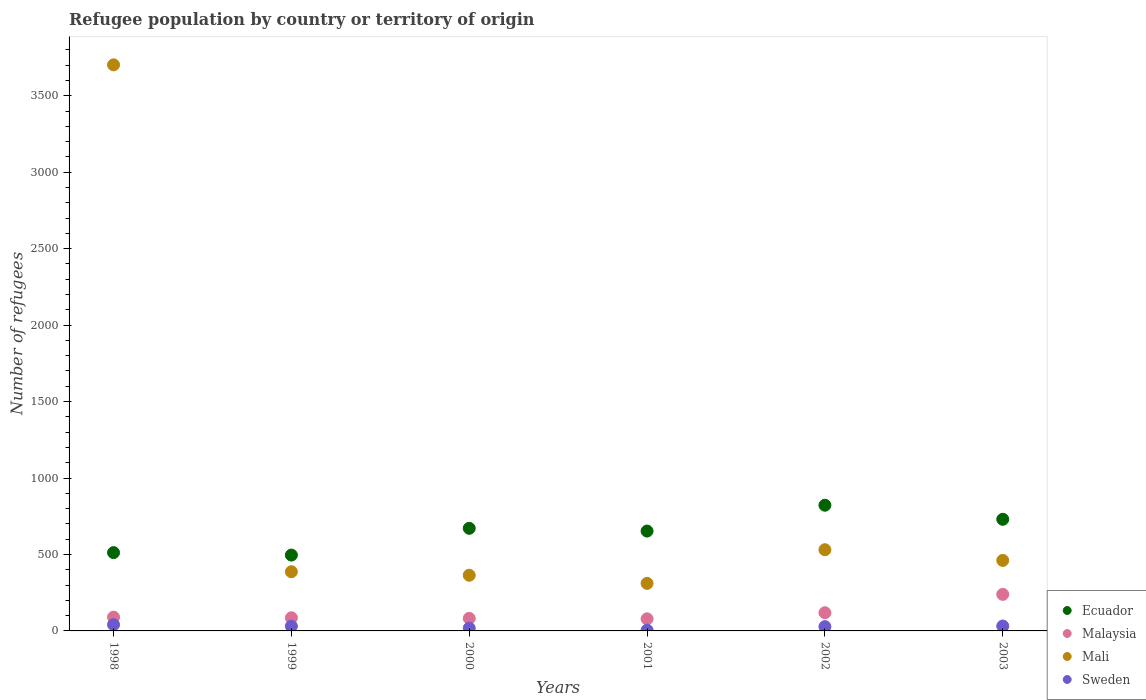How many different coloured dotlines are there?
Offer a terse response. 4. Is the number of dotlines equal to the number of legend labels?
Your answer should be compact. Yes. What is the number of refugees in Mali in 1998?
Keep it short and to the point. 3702. Across all years, what is the maximum number of refugees in Mali?
Your response must be concise. 3702. Across all years, what is the minimum number of refugees in Malaysia?
Keep it short and to the point. 79. What is the total number of refugees in Mali in the graph?
Your answer should be compact. 5756. What is the difference between the number of refugees in Sweden in 1998 and that in 1999?
Offer a terse response. 10. What is the difference between the number of refugees in Ecuador in 1999 and the number of refugees in Mali in 2001?
Your answer should be very brief. 185. What is the average number of refugees in Sweden per year?
Your response must be concise. 25.83. In the year 1999, what is the difference between the number of refugees in Malaysia and number of refugees in Ecuador?
Provide a short and direct response. -410. What is the ratio of the number of refugees in Malaysia in 2000 to that in 2001?
Provide a short and direct response. 1.04. Is the difference between the number of refugees in Malaysia in 1998 and 1999 greater than the difference between the number of refugees in Ecuador in 1998 and 1999?
Offer a very short reply. No. What is the difference between the highest and the second highest number of refugees in Mali?
Your answer should be very brief. 3171. Is it the case that in every year, the sum of the number of refugees in Mali and number of refugees in Malaysia  is greater than the sum of number of refugees in Sweden and number of refugees in Ecuador?
Make the answer very short. No. Is it the case that in every year, the sum of the number of refugees in Malaysia and number of refugees in Ecuador  is greater than the number of refugees in Sweden?
Make the answer very short. Yes. Is the number of refugees in Ecuador strictly greater than the number of refugees in Malaysia over the years?
Your response must be concise. Yes. Is the number of refugees in Ecuador strictly less than the number of refugees in Malaysia over the years?
Provide a short and direct response. No. How many dotlines are there?
Give a very brief answer. 4. How many years are there in the graph?
Give a very brief answer. 6. Does the graph contain grids?
Your answer should be compact. No. Where does the legend appear in the graph?
Your answer should be compact. Bottom right. What is the title of the graph?
Offer a terse response. Refugee population by country or territory of origin. What is the label or title of the X-axis?
Ensure brevity in your answer.  Years. What is the label or title of the Y-axis?
Your answer should be compact. Number of refugees. What is the Number of refugees in Ecuador in 1998?
Your response must be concise. 512. What is the Number of refugees of Malaysia in 1998?
Your response must be concise. 90. What is the Number of refugees of Mali in 1998?
Provide a short and direct response. 3702. What is the Number of refugees of Sweden in 1998?
Ensure brevity in your answer.  41. What is the Number of refugees in Ecuador in 1999?
Give a very brief answer. 496. What is the Number of refugees in Malaysia in 1999?
Your response must be concise. 86. What is the Number of refugees in Mali in 1999?
Make the answer very short. 387. What is the Number of refugees in Ecuador in 2000?
Provide a short and direct response. 671. What is the Number of refugees in Mali in 2000?
Offer a very short reply. 364. What is the Number of refugees of Sweden in 2000?
Make the answer very short. 18. What is the Number of refugees in Ecuador in 2001?
Make the answer very short. 653. What is the Number of refugees of Malaysia in 2001?
Your answer should be very brief. 79. What is the Number of refugees in Mali in 2001?
Offer a very short reply. 311. What is the Number of refugees of Sweden in 2001?
Ensure brevity in your answer.  5. What is the Number of refugees of Ecuador in 2002?
Provide a succinct answer. 822. What is the Number of refugees in Malaysia in 2002?
Make the answer very short. 119. What is the Number of refugees in Mali in 2002?
Your response must be concise. 531. What is the Number of refugees in Sweden in 2002?
Keep it short and to the point. 28. What is the Number of refugees of Ecuador in 2003?
Keep it short and to the point. 730. What is the Number of refugees in Malaysia in 2003?
Give a very brief answer. 239. What is the Number of refugees in Mali in 2003?
Ensure brevity in your answer.  461. Across all years, what is the maximum Number of refugees of Ecuador?
Ensure brevity in your answer.  822. Across all years, what is the maximum Number of refugees in Malaysia?
Keep it short and to the point. 239. Across all years, what is the maximum Number of refugees of Mali?
Keep it short and to the point. 3702. Across all years, what is the minimum Number of refugees of Ecuador?
Offer a terse response. 496. Across all years, what is the minimum Number of refugees in Malaysia?
Offer a terse response. 79. Across all years, what is the minimum Number of refugees in Mali?
Your answer should be compact. 311. Across all years, what is the minimum Number of refugees in Sweden?
Give a very brief answer. 5. What is the total Number of refugees in Ecuador in the graph?
Ensure brevity in your answer.  3884. What is the total Number of refugees in Malaysia in the graph?
Your response must be concise. 695. What is the total Number of refugees of Mali in the graph?
Ensure brevity in your answer.  5756. What is the total Number of refugees of Sweden in the graph?
Your answer should be very brief. 155. What is the difference between the Number of refugees of Ecuador in 1998 and that in 1999?
Offer a terse response. 16. What is the difference between the Number of refugees in Mali in 1998 and that in 1999?
Keep it short and to the point. 3315. What is the difference between the Number of refugees in Ecuador in 1998 and that in 2000?
Provide a short and direct response. -159. What is the difference between the Number of refugees in Mali in 1998 and that in 2000?
Keep it short and to the point. 3338. What is the difference between the Number of refugees of Ecuador in 1998 and that in 2001?
Your answer should be very brief. -141. What is the difference between the Number of refugees of Mali in 1998 and that in 2001?
Give a very brief answer. 3391. What is the difference between the Number of refugees of Ecuador in 1998 and that in 2002?
Offer a terse response. -310. What is the difference between the Number of refugees in Mali in 1998 and that in 2002?
Ensure brevity in your answer.  3171. What is the difference between the Number of refugees of Ecuador in 1998 and that in 2003?
Provide a short and direct response. -218. What is the difference between the Number of refugees in Malaysia in 1998 and that in 2003?
Your answer should be compact. -149. What is the difference between the Number of refugees of Mali in 1998 and that in 2003?
Offer a terse response. 3241. What is the difference between the Number of refugees of Sweden in 1998 and that in 2003?
Your answer should be compact. 9. What is the difference between the Number of refugees in Ecuador in 1999 and that in 2000?
Provide a short and direct response. -175. What is the difference between the Number of refugees in Malaysia in 1999 and that in 2000?
Give a very brief answer. 4. What is the difference between the Number of refugees in Ecuador in 1999 and that in 2001?
Ensure brevity in your answer.  -157. What is the difference between the Number of refugees in Mali in 1999 and that in 2001?
Offer a terse response. 76. What is the difference between the Number of refugees of Ecuador in 1999 and that in 2002?
Ensure brevity in your answer.  -326. What is the difference between the Number of refugees in Malaysia in 1999 and that in 2002?
Give a very brief answer. -33. What is the difference between the Number of refugees in Mali in 1999 and that in 2002?
Your answer should be very brief. -144. What is the difference between the Number of refugees of Sweden in 1999 and that in 2002?
Your response must be concise. 3. What is the difference between the Number of refugees in Ecuador in 1999 and that in 2003?
Offer a very short reply. -234. What is the difference between the Number of refugees in Malaysia in 1999 and that in 2003?
Provide a short and direct response. -153. What is the difference between the Number of refugees in Mali in 1999 and that in 2003?
Your answer should be compact. -74. What is the difference between the Number of refugees of Sweden in 1999 and that in 2003?
Your answer should be very brief. -1. What is the difference between the Number of refugees in Ecuador in 2000 and that in 2001?
Offer a very short reply. 18. What is the difference between the Number of refugees in Malaysia in 2000 and that in 2001?
Ensure brevity in your answer.  3. What is the difference between the Number of refugees of Ecuador in 2000 and that in 2002?
Offer a terse response. -151. What is the difference between the Number of refugees of Malaysia in 2000 and that in 2002?
Provide a short and direct response. -37. What is the difference between the Number of refugees in Mali in 2000 and that in 2002?
Your response must be concise. -167. What is the difference between the Number of refugees of Sweden in 2000 and that in 2002?
Your response must be concise. -10. What is the difference between the Number of refugees of Ecuador in 2000 and that in 2003?
Provide a short and direct response. -59. What is the difference between the Number of refugees in Malaysia in 2000 and that in 2003?
Provide a short and direct response. -157. What is the difference between the Number of refugees in Mali in 2000 and that in 2003?
Your answer should be compact. -97. What is the difference between the Number of refugees of Ecuador in 2001 and that in 2002?
Keep it short and to the point. -169. What is the difference between the Number of refugees in Mali in 2001 and that in 2002?
Offer a terse response. -220. What is the difference between the Number of refugees in Sweden in 2001 and that in 2002?
Offer a very short reply. -23. What is the difference between the Number of refugees in Ecuador in 2001 and that in 2003?
Offer a terse response. -77. What is the difference between the Number of refugees of Malaysia in 2001 and that in 2003?
Keep it short and to the point. -160. What is the difference between the Number of refugees of Mali in 2001 and that in 2003?
Ensure brevity in your answer.  -150. What is the difference between the Number of refugees of Ecuador in 2002 and that in 2003?
Ensure brevity in your answer.  92. What is the difference between the Number of refugees of Malaysia in 2002 and that in 2003?
Keep it short and to the point. -120. What is the difference between the Number of refugees in Mali in 2002 and that in 2003?
Give a very brief answer. 70. What is the difference between the Number of refugees in Sweden in 2002 and that in 2003?
Provide a short and direct response. -4. What is the difference between the Number of refugees in Ecuador in 1998 and the Number of refugees in Malaysia in 1999?
Give a very brief answer. 426. What is the difference between the Number of refugees in Ecuador in 1998 and the Number of refugees in Mali in 1999?
Provide a succinct answer. 125. What is the difference between the Number of refugees of Ecuador in 1998 and the Number of refugees of Sweden in 1999?
Provide a short and direct response. 481. What is the difference between the Number of refugees in Malaysia in 1998 and the Number of refugees in Mali in 1999?
Keep it short and to the point. -297. What is the difference between the Number of refugees of Malaysia in 1998 and the Number of refugees of Sweden in 1999?
Your answer should be very brief. 59. What is the difference between the Number of refugees in Mali in 1998 and the Number of refugees in Sweden in 1999?
Offer a very short reply. 3671. What is the difference between the Number of refugees of Ecuador in 1998 and the Number of refugees of Malaysia in 2000?
Keep it short and to the point. 430. What is the difference between the Number of refugees in Ecuador in 1998 and the Number of refugees in Mali in 2000?
Offer a terse response. 148. What is the difference between the Number of refugees of Ecuador in 1998 and the Number of refugees of Sweden in 2000?
Your answer should be compact. 494. What is the difference between the Number of refugees in Malaysia in 1998 and the Number of refugees in Mali in 2000?
Your answer should be compact. -274. What is the difference between the Number of refugees of Mali in 1998 and the Number of refugees of Sweden in 2000?
Your answer should be very brief. 3684. What is the difference between the Number of refugees in Ecuador in 1998 and the Number of refugees in Malaysia in 2001?
Provide a succinct answer. 433. What is the difference between the Number of refugees of Ecuador in 1998 and the Number of refugees of Mali in 2001?
Your answer should be very brief. 201. What is the difference between the Number of refugees of Ecuador in 1998 and the Number of refugees of Sweden in 2001?
Offer a terse response. 507. What is the difference between the Number of refugees of Malaysia in 1998 and the Number of refugees of Mali in 2001?
Offer a terse response. -221. What is the difference between the Number of refugees in Malaysia in 1998 and the Number of refugees in Sweden in 2001?
Offer a terse response. 85. What is the difference between the Number of refugees in Mali in 1998 and the Number of refugees in Sweden in 2001?
Keep it short and to the point. 3697. What is the difference between the Number of refugees in Ecuador in 1998 and the Number of refugees in Malaysia in 2002?
Your answer should be compact. 393. What is the difference between the Number of refugees in Ecuador in 1998 and the Number of refugees in Sweden in 2002?
Keep it short and to the point. 484. What is the difference between the Number of refugees in Malaysia in 1998 and the Number of refugees in Mali in 2002?
Your answer should be very brief. -441. What is the difference between the Number of refugees of Malaysia in 1998 and the Number of refugees of Sweden in 2002?
Ensure brevity in your answer.  62. What is the difference between the Number of refugees of Mali in 1998 and the Number of refugees of Sweden in 2002?
Provide a short and direct response. 3674. What is the difference between the Number of refugees of Ecuador in 1998 and the Number of refugees of Malaysia in 2003?
Your answer should be compact. 273. What is the difference between the Number of refugees of Ecuador in 1998 and the Number of refugees of Mali in 2003?
Your response must be concise. 51. What is the difference between the Number of refugees of Ecuador in 1998 and the Number of refugees of Sweden in 2003?
Your answer should be very brief. 480. What is the difference between the Number of refugees of Malaysia in 1998 and the Number of refugees of Mali in 2003?
Offer a very short reply. -371. What is the difference between the Number of refugees of Mali in 1998 and the Number of refugees of Sweden in 2003?
Give a very brief answer. 3670. What is the difference between the Number of refugees of Ecuador in 1999 and the Number of refugees of Malaysia in 2000?
Keep it short and to the point. 414. What is the difference between the Number of refugees in Ecuador in 1999 and the Number of refugees in Mali in 2000?
Offer a terse response. 132. What is the difference between the Number of refugees in Ecuador in 1999 and the Number of refugees in Sweden in 2000?
Your answer should be compact. 478. What is the difference between the Number of refugees of Malaysia in 1999 and the Number of refugees of Mali in 2000?
Your response must be concise. -278. What is the difference between the Number of refugees of Mali in 1999 and the Number of refugees of Sweden in 2000?
Provide a succinct answer. 369. What is the difference between the Number of refugees of Ecuador in 1999 and the Number of refugees of Malaysia in 2001?
Offer a terse response. 417. What is the difference between the Number of refugees of Ecuador in 1999 and the Number of refugees of Mali in 2001?
Ensure brevity in your answer.  185. What is the difference between the Number of refugees of Ecuador in 1999 and the Number of refugees of Sweden in 2001?
Your answer should be very brief. 491. What is the difference between the Number of refugees in Malaysia in 1999 and the Number of refugees in Mali in 2001?
Make the answer very short. -225. What is the difference between the Number of refugees of Mali in 1999 and the Number of refugees of Sweden in 2001?
Give a very brief answer. 382. What is the difference between the Number of refugees in Ecuador in 1999 and the Number of refugees in Malaysia in 2002?
Offer a very short reply. 377. What is the difference between the Number of refugees in Ecuador in 1999 and the Number of refugees in Mali in 2002?
Give a very brief answer. -35. What is the difference between the Number of refugees of Ecuador in 1999 and the Number of refugees of Sweden in 2002?
Provide a succinct answer. 468. What is the difference between the Number of refugees of Malaysia in 1999 and the Number of refugees of Mali in 2002?
Provide a succinct answer. -445. What is the difference between the Number of refugees of Malaysia in 1999 and the Number of refugees of Sweden in 2002?
Make the answer very short. 58. What is the difference between the Number of refugees of Mali in 1999 and the Number of refugees of Sweden in 2002?
Offer a terse response. 359. What is the difference between the Number of refugees of Ecuador in 1999 and the Number of refugees of Malaysia in 2003?
Provide a succinct answer. 257. What is the difference between the Number of refugees of Ecuador in 1999 and the Number of refugees of Sweden in 2003?
Your answer should be very brief. 464. What is the difference between the Number of refugees of Malaysia in 1999 and the Number of refugees of Mali in 2003?
Provide a succinct answer. -375. What is the difference between the Number of refugees of Mali in 1999 and the Number of refugees of Sweden in 2003?
Offer a very short reply. 355. What is the difference between the Number of refugees in Ecuador in 2000 and the Number of refugees in Malaysia in 2001?
Ensure brevity in your answer.  592. What is the difference between the Number of refugees in Ecuador in 2000 and the Number of refugees in Mali in 2001?
Offer a terse response. 360. What is the difference between the Number of refugees of Ecuador in 2000 and the Number of refugees of Sweden in 2001?
Offer a terse response. 666. What is the difference between the Number of refugees of Malaysia in 2000 and the Number of refugees of Mali in 2001?
Provide a short and direct response. -229. What is the difference between the Number of refugees in Malaysia in 2000 and the Number of refugees in Sweden in 2001?
Your response must be concise. 77. What is the difference between the Number of refugees of Mali in 2000 and the Number of refugees of Sweden in 2001?
Your answer should be compact. 359. What is the difference between the Number of refugees in Ecuador in 2000 and the Number of refugees in Malaysia in 2002?
Your response must be concise. 552. What is the difference between the Number of refugees in Ecuador in 2000 and the Number of refugees in Mali in 2002?
Give a very brief answer. 140. What is the difference between the Number of refugees in Ecuador in 2000 and the Number of refugees in Sweden in 2002?
Your answer should be very brief. 643. What is the difference between the Number of refugees in Malaysia in 2000 and the Number of refugees in Mali in 2002?
Offer a terse response. -449. What is the difference between the Number of refugees of Mali in 2000 and the Number of refugees of Sweden in 2002?
Your answer should be very brief. 336. What is the difference between the Number of refugees in Ecuador in 2000 and the Number of refugees in Malaysia in 2003?
Offer a terse response. 432. What is the difference between the Number of refugees of Ecuador in 2000 and the Number of refugees of Mali in 2003?
Your answer should be very brief. 210. What is the difference between the Number of refugees of Ecuador in 2000 and the Number of refugees of Sweden in 2003?
Provide a short and direct response. 639. What is the difference between the Number of refugees in Malaysia in 2000 and the Number of refugees in Mali in 2003?
Your answer should be compact. -379. What is the difference between the Number of refugees of Malaysia in 2000 and the Number of refugees of Sweden in 2003?
Your response must be concise. 50. What is the difference between the Number of refugees of Mali in 2000 and the Number of refugees of Sweden in 2003?
Ensure brevity in your answer.  332. What is the difference between the Number of refugees in Ecuador in 2001 and the Number of refugees in Malaysia in 2002?
Provide a succinct answer. 534. What is the difference between the Number of refugees of Ecuador in 2001 and the Number of refugees of Mali in 2002?
Your answer should be compact. 122. What is the difference between the Number of refugees in Ecuador in 2001 and the Number of refugees in Sweden in 2002?
Give a very brief answer. 625. What is the difference between the Number of refugees in Malaysia in 2001 and the Number of refugees in Mali in 2002?
Offer a terse response. -452. What is the difference between the Number of refugees in Malaysia in 2001 and the Number of refugees in Sweden in 2002?
Offer a terse response. 51. What is the difference between the Number of refugees in Mali in 2001 and the Number of refugees in Sweden in 2002?
Provide a succinct answer. 283. What is the difference between the Number of refugees of Ecuador in 2001 and the Number of refugees of Malaysia in 2003?
Provide a short and direct response. 414. What is the difference between the Number of refugees in Ecuador in 2001 and the Number of refugees in Mali in 2003?
Provide a succinct answer. 192. What is the difference between the Number of refugees in Ecuador in 2001 and the Number of refugees in Sweden in 2003?
Make the answer very short. 621. What is the difference between the Number of refugees in Malaysia in 2001 and the Number of refugees in Mali in 2003?
Ensure brevity in your answer.  -382. What is the difference between the Number of refugees of Mali in 2001 and the Number of refugees of Sweden in 2003?
Your response must be concise. 279. What is the difference between the Number of refugees in Ecuador in 2002 and the Number of refugees in Malaysia in 2003?
Your answer should be very brief. 583. What is the difference between the Number of refugees in Ecuador in 2002 and the Number of refugees in Mali in 2003?
Provide a short and direct response. 361. What is the difference between the Number of refugees in Ecuador in 2002 and the Number of refugees in Sweden in 2003?
Your response must be concise. 790. What is the difference between the Number of refugees of Malaysia in 2002 and the Number of refugees of Mali in 2003?
Make the answer very short. -342. What is the difference between the Number of refugees of Malaysia in 2002 and the Number of refugees of Sweden in 2003?
Offer a terse response. 87. What is the difference between the Number of refugees of Mali in 2002 and the Number of refugees of Sweden in 2003?
Offer a terse response. 499. What is the average Number of refugees of Ecuador per year?
Ensure brevity in your answer.  647.33. What is the average Number of refugees of Malaysia per year?
Keep it short and to the point. 115.83. What is the average Number of refugees of Mali per year?
Your answer should be compact. 959.33. What is the average Number of refugees of Sweden per year?
Your response must be concise. 25.83. In the year 1998, what is the difference between the Number of refugees in Ecuador and Number of refugees in Malaysia?
Your response must be concise. 422. In the year 1998, what is the difference between the Number of refugees of Ecuador and Number of refugees of Mali?
Keep it short and to the point. -3190. In the year 1998, what is the difference between the Number of refugees in Ecuador and Number of refugees in Sweden?
Give a very brief answer. 471. In the year 1998, what is the difference between the Number of refugees of Malaysia and Number of refugees of Mali?
Provide a succinct answer. -3612. In the year 1998, what is the difference between the Number of refugees of Mali and Number of refugees of Sweden?
Give a very brief answer. 3661. In the year 1999, what is the difference between the Number of refugees of Ecuador and Number of refugees of Malaysia?
Your answer should be very brief. 410. In the year 1999, what is the difference between the Number of refugees of Ecuador and Number of refugees of Mali?
Your answer should be very brief. 109. In the year 1999, what is the difference between the Number of refugees in Ecuador and Number of refugees in Sweden?
Offer a terse response. 465. In the year 1999, what is the difference between the Number of refugees of Malaysia and Number of refugees of Mali?
Provide a succinct answer. -301. In the year 1999, what is the difference between the Number of refugees of Mali and Number of refugees of Sweden?
Offer a very short reply. 356. In the year 2000, what is the difference between the Number of refugees in Ecuador and Number of refugees in Malaysia?
Offer a terse response. 589. In the year 2000, what is the difference between the Number of refugees of Ecuador and Number of refugees of Mali?
Provide a short and direct response. 307. In the year 2000, what is the difference between the Number of refugees of Ecuador and Number of refugees of Sweden?
Provide a short and direct response. 653. In the year 2000, what is the difference between the Number of refugees in Malaysia and Number of refugees in Mali?
Make the answer very short. -282. In the year 2000, what is the difference between the Number of refugees of Malaysia and Number of refugees of Sweden?
Your response must be concise. 64. In the year 2000, what is the difference between the Number of refugees of Mali and Number of refugees of Sweden?
Your response must be concise. 346. In the year 2001, what is the difference between the Number of refugees in Ecuador and Number of refugees in Malaysia?
Your response must be concise. 574. In the year 2001, what is the difference between the Number of refugees in Ecuador and Number of refugees in Mali?
Your response must be concise. 342. In the year 2001, what is the difference between the Number of refugees in Ecuador and Number of refugees in Sweden?
Make the answer very short. 648. In the year 2001, what is the difference between the Number of refugees of Malaysia and Number of refugees of Mali?
Your answer should be very brief. -232. In the year 2001, what is the difference between the Number of refugees of Malaysia and Number of refugees of Sweden?
Ensure brevity in your answer.  74. In the year 2001, what is the difference between the Number of refugees of Mali and Number of refugees of Sweden?
Keep it short and to the point. 306. In the year 2002, what is the difference between the Number of refugees in Ecuador and Number of refugees in Malaysia?
Provide a succinct answer. 703. In the year 2002, what is the difference between the Number of refugees in Ecuador and Number of refugees in Mali?
Your answer should be compact. 291. In the year 2002, what is the difference between the Number of refugees of Ecuador and Number of refugees of Sweden?
Give a very brief answer. 794. In the year 2002, what is the difference between the Number of refugees in Malaysia and Number of refugees in Mali?
Offer a terse response. -412. In the year 2002, what is the difference between the Number of refugees of Malaysia and Number of refugees of Sweden?
Offer a very short reply. 91. In the year 2002, what is the difference between the Number of refugees in Mali and Number of refugees in Sweden?
Your response must be concise. 503. In the year 2003, what is the difference between the Number of refugees in Ecuador and Number of refugees in Malaysia?
Offer a very short reply. 491. In the year 2003, what is the difference between the Number of refugees in Ecuador and Number of refugees in Mali?
Keep it short and to the point. 269. In the year 2003, what is the difference between the Number of refugees of Ecuador and Number of refugees of Sweden?
Keep it short and to the point. 698. In the year 2003, what is the difference between the Number of refugees of Malaysia and Number of refugees of Mali?
Offer a terse response. -222. In the year 2003, what is the difference between the Number of refugees of Malaysia and Number of refugees of Sweden?
Your answer should be very brief. 207. In the year 2003, what is the difference between the Number of refugees of Mali and Number of refugees of Sweden?
Your answer should be compact. 429. What is the ratio of the Number of refugees in Ecuador in 1998 to that in 1999?
Ensure brevity in your answer.  1.03. What is the ratio of the Number of refugees in Malaysia in 1998 to that in 1999?
Offer a terse response. 1.05. What is the ratio of the Number of refugees in Mali in 1998 to that in 1999?
Provide a short and direct response. 9.57. What is the ratio of the Number of refugees in Sweden in 1998 to that in 1999?
Offer a very short reply. 1.32. What is the ratio of the Number of refugees in Ecuador in 1998 to that in 2000?
Provide a short and direct response. 0.76. What is the ratio of the Number of refugees of Malaysia in 1998 to that in 2000?
Your answer should be compact. 1.1. What is the ratio of the Number of refugees in Mali in 1998 to that in 2000?
Your answer should be very brief. 10.17. What is the ratio of the Number of refugees of Sweden in 1998 to that in 2000?
Your answer should be compact. 2.28. What is the ratio of the Number of refugees of Ecuador in 1998 to that in 2001?
Keep it short and to the point. 0.78. What is the ratio of the Number of refugees in Malaysia in 1998 to that in 2001?
Your answer should be compact. 1.14. What is the ratio of the Number of refugees of Mali in 1998 to that in 2001?
Your answer should be very brief. 11.9. What is the ratio of the Number of refugees of Ecuador in 1998 to that in 2002?
Provide a short and direct response. 0.62. What is the ratio of the Number of refugees of Malaysia in 1998 to that in 2002?
Your response must be concise. 0.76. What is the ratio of the Number of refugees in Mali in 1998 to that in 2002?
Keep it short and to the point. 6.97. What is the ratio of the Number of refugees in Sweden in 1998 to that in 2002?
Offer a terse response. 1.46. What is the ratio of the Number of refugees of Ecuador in 1998 to that in 2003?
Offer a very short reply. 0.7. What is the ratio of the Number of refugees of Malaysia in 1998 to that in 2003?
Offer a very short reply. 0.38. What is the ratio of the Number of refugees in Mali in 1998 to that in 2003?
Your answer should be compact. 8.03. What is the ratio of the Number of refugees in Sweden in 1998 to that in 2003?
Provide a short and direct response. 1.28. What is the ratio of the Number of refugees in Ecuador in 1999 to that in 2000?
Offer a terse response. 0.74. What is the ratio of the Number of refugees in Malaysia in 1999 to that in 2000?
Offer a terse response. 1.05. What is the ratio of the Number of refugees in Mali in 1999 to that in 2000?
Offer a terse response. 1.06. What is the ratio of the Number of refugees of Sweden in 1999 to that in 2000?
Make the answer very short. 1.72. What is the ratio of the Number of refugees in Ecuador in 1999 to that in 2001?
Make the answer very short. 0.76. What is the ratio of the Number of refugees of Malaysia in 1999 to that in 2001?
Make the answer very short. 1.09. What is the ratio of the Number of refugees in Mali in 1999 to that in 2001?
Keep it short and to the point. 1.24. What is the ratio of the Number of refugees in Sweden in 1999 to that in 2001?
Make the answer very short. 6.2. What is the ratio of the Number of refugees in Ecuador in 1999 to that in 2002?
Ensure brevity in your answer.  0.6. What is the ratio of the Number of refugees of Malaysia in 1999 to that in 2002?
Provide a short and direct response. 0.72. What is the ratio of the Number of refugees in Mali in 1999 to that in 2002?
Make the answer very short. 0.73. What is the ratio of the Number of refugees in Sweden in 1999 to that in 2002?
Your response must be concise. 1.11. What is the ratio of the Number of refugees of Ecuador in 1999 to that in 2003?
Ensure brevity in your answer.  0.68. What is the ratio of the Number of refugees of Malaysia in 1999 to that in 2003?
Give a very brief answer. 0.36. What is the ratio of the Number of refugees of Mali in 1999 to that in 2003?
Ensure brevity in your answer.  0.84. What is the ratio of the Number of refugees of Sweden in 1999 to that in 2003?
Provide a succinct answer. 0.97. What is the ratio of the Number of refugees of Ecuador in 2000 to that in 2001?
Your answer should be compact. 1.03. What is the ratio of the Number of refugees of Malaysia in 2000 to that in 2001?
Make the answer very short. 1.04. What is the ratio of the Number of refugees in Mali in 2000 to that in 2001?
Offer a terse response. 1.17. What is the ratio of the Number of refugees of Sweden in 2000 to that in 2001?
Give a very brief answer. 3.6. What is the ratio of the Number of refugees of Ecuador in 2000 to that in 2002?
Provide a short and direct response. 0.82. What is the ratio of the Number of refugees in Malaysia in 2000 to that in 2002?
Provide a succinct answer. 0.69. What is the ratio of the Number of refugees of Mali in 2000 to that in 2002?
Your answer should be compact. 0.69. What is the ratio of the Number of refugees of Sweden in 2000 to that in 2002?
Ensure brevity in your answer.  0.64. What is the ratio of the Number of refugees of Ecuador in 2000 to that in 2003?
Keep it short and to the point. 0.92. What is the ratio of the Number of refugees in Malaysia in 2000 to that in 2003?
Offer a terse response. 0.34. What is the ratio of the Number of refugees of Mali in 2000 to that in 2003?
Your response must be concise. 0.79. What is the ratio of the Number of refugees of Sweden in 2000 to that in 2003?
Your response must be concise. 0.56. What is the ratio of the Number of refugees in Ecuador in 2001 to that in 2002?
Make the answer very short. 0.79. What is the ratio of the Number of refugees of Malaysia in 2001 to that in 2002?
Provide a short and direct response. 0.66. What is the ratio of the Number of refugees of Mali in 2001 to that in 2002?
Your response must be concise. 0.59. What is the ratio of the Number of refugees of Sweden in 2001 to that in 2002?
Give a very brief answer. 0.18. What is the ratio of the Number of refugees of Ecuador in 2001 to that in 2003?
Your answer should be very brief. 0.89. What is the ratio of the Number of refugees of Malaysia in 2001 to that in 2003?
Offer a terse response. 0.33. What is the ratio of the Number of refugees in Mali in 2001 to that in 2003?
Make the answer very short. 0.67. What is the ratio of the Number of refugees of Sweden in 2001 to that in 2003?
Offer a terse response. 0.16. What is the ratio of the Number of refugees of Ecuador in 2002 to that in 2003?
Provide a succinct answer. 1.13. What is the ratio of the Number of refugees in Malaysia in 2002 to that in 2003?
Ensure brevity in your answer.  0.5. What is the ratio of the Number of refugees in Mali in 2002 to that in 2003?
Your response must be concise. 1.15. What is the ratio of the Number of refugees in Sweden in 2002 to that in 2003?
Give a very brief answer. 0.88. What is the difference between the highest and the second highest Number of refugees in Ecuador?
Make the answer very short. 92. What is the difference between the highest and the second highest Number of refugees of Malaysia?
Your response must be concise. 120. What is the difference between the highest and the second highest Number of refugees of Mali?
Offer a very short reply. 3171. What is the difference between the highest and the lowest Number of refugees in Ecuador?
Your answer should be very brief. 326. What is the difference between the highest and the lowest Number of refugees in Malaysia?
Make the answer very short. 160. What is the difference between the highest and the lowest Number of refugees of Mali?
Provide a succinct answer. 3391. 